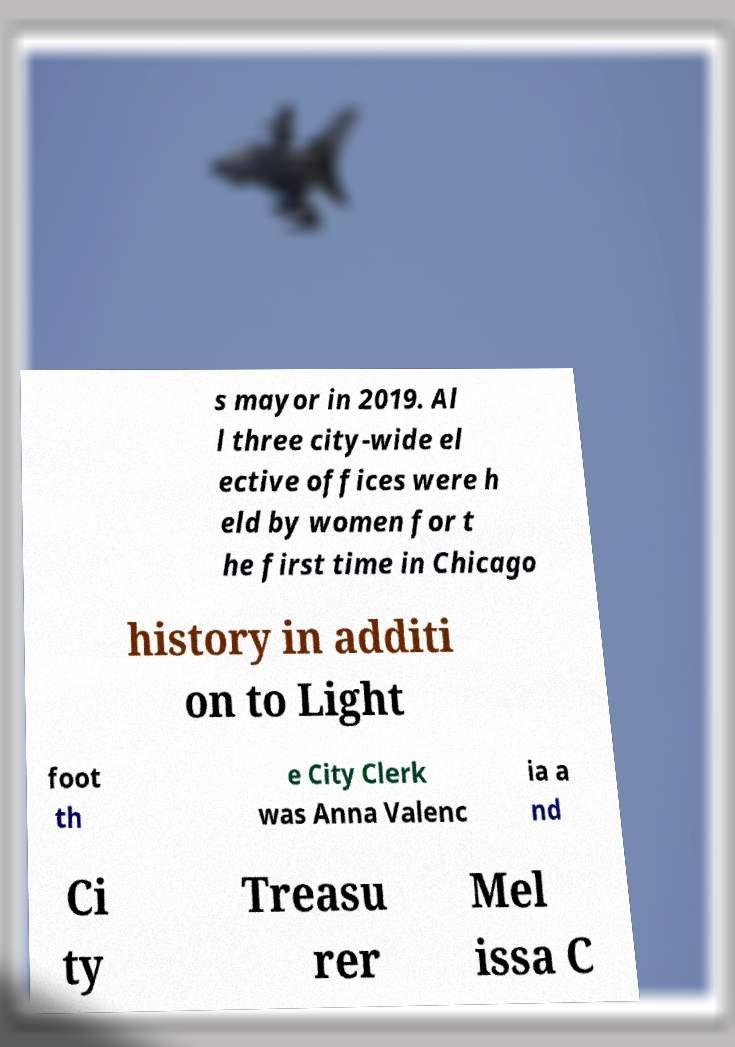I need the written content from this picture converted into text. Can you do that? s mayor in 2019. Al l three city-wide el ective offices were h eld by women for t he first time in Chicago history in additi on to Light foot th e City Clerk was Anna Valenc ia a nd Ci ty Treasu rer Mel issa C 